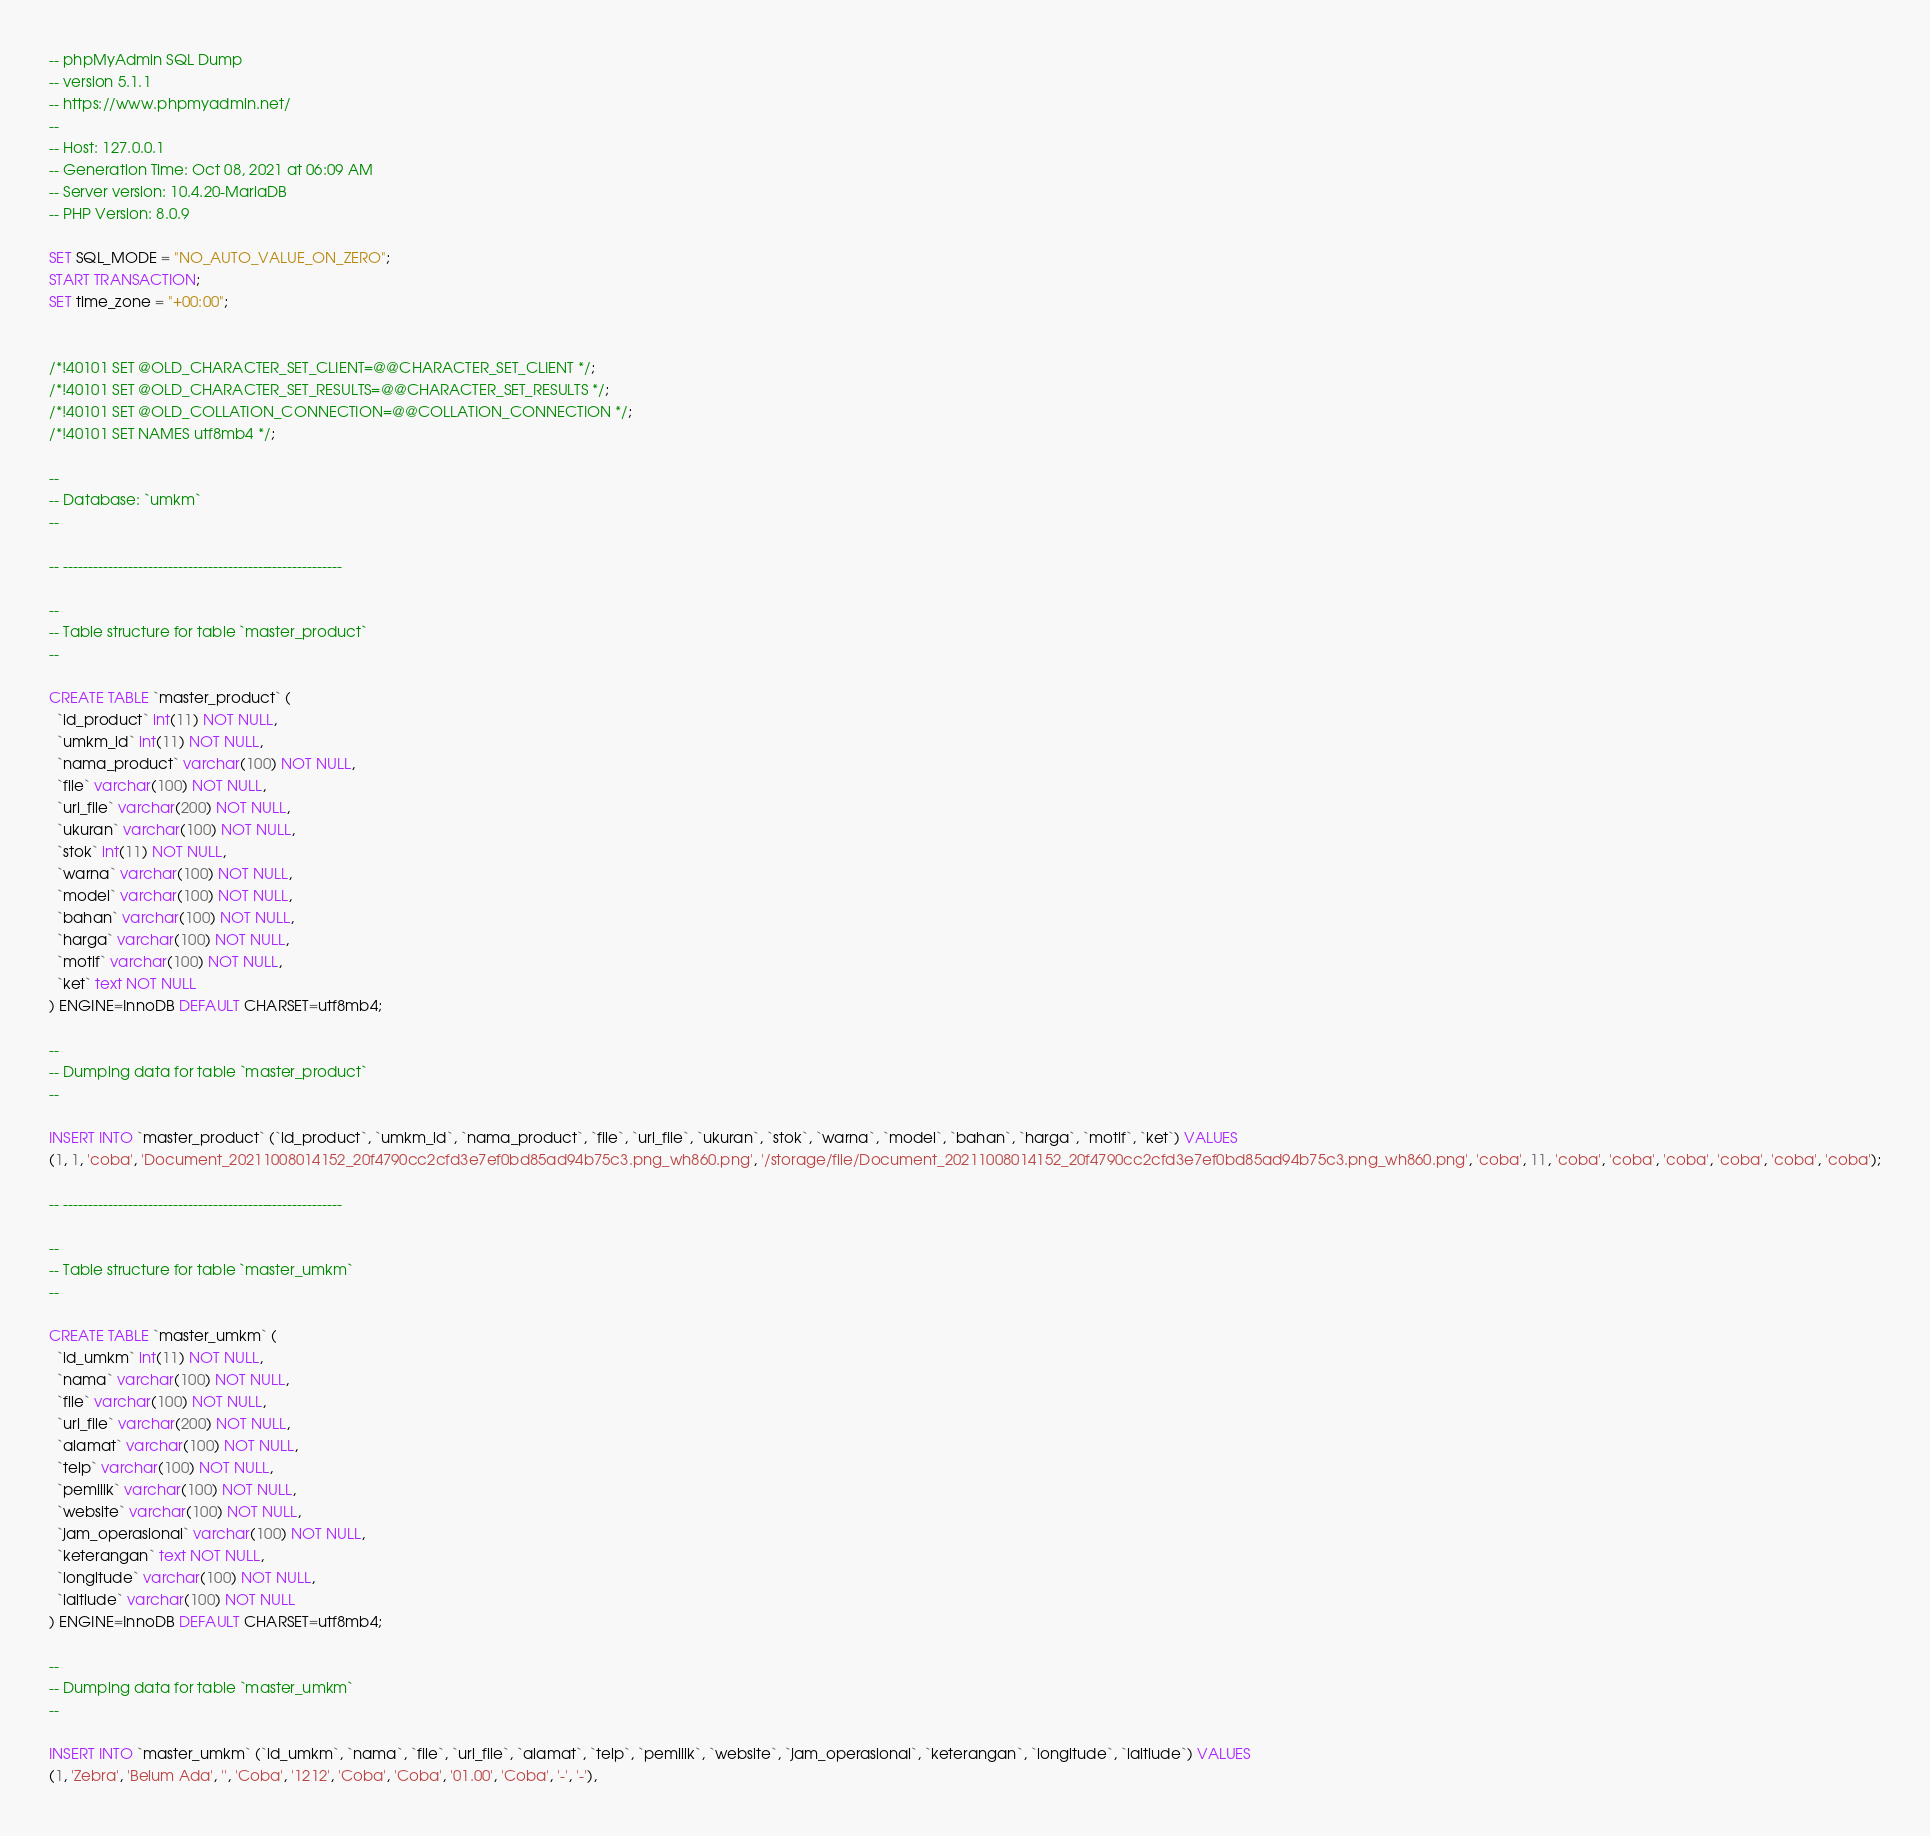Convert code to text. <code><loc_0><loc_0><loc_500><loc_500><_SQL_>-- phpMyAdmin SQL Dump
-- version 5.1.1
-- https://www.phpmyadmin.net/
--
-- Host: 127.0.0.1
-- Generation Time: Oct 08, 2021 at 06:09 AM
-- Server version: 10.4.20-MariaDB
-- PHP Version: 8.0.9

SET SQL_MODE = "NO_AUTO_VALUE_ON_ZERO";
START TRANSACTION;
SET time_zone = "+00:00";


/*!40101 SET @OLD_CHARACTER_SET_CLIENT=@@CHARACTER_SET_CLIENT */;
/*!40101 SET @OLD_CHARACTER_SET_RESULTS=@@CHARACTER_SET_RESULTS */;
/*!40101 SET @OLD_COLLATION_CONNECTION=@@COLLATION_CONNECTION */;
/*!40101 SET NAMES utf8mb4 */;

--
-- Database: `umkm`
--

-- --------------------------------------------------------

--
-- Table structure for table `master_product`
--

CREATE TABLE `master_product` (
  `id_product` int(11) NOT NULL,
  `umkm_id` int(11) NOT NULL,
  `nama_product` varchar(100) NOT NULL,
  `file` varchar(100) NOT NULL,
  `url_file` varchar(200) NOT NULL,
  `ukuran` varchar(100) NOT NULL,
  `stok` int(11) NOT NULL,
  `warna` varchar(100) NOT NULL,
  `model` varchar(100) NOT NULL,
  `bahan` varchar(100) NOT NULL,
  `harga` varchar(100) NOT NULL,
  `motif` varchar(100) NOT NULL,
  `ket` text NOT NULL
) ENGINE=InnoDB DEFAULT CHARSET=utf8mb4;

--
-- Dumping data for table `master_product`
--

INSERT INTO `master_product` (`id_product`, `umkm_id`, `nama_product`, `file`, `url_file`, `ukuran`, `stok`, `warna`, `model`, `bahan`, `harga`, `motif`, `ket`) VALUES
(1, 1, 'coba', 'Document_20211008014152_20f4790cc2cfd3e7ef0bd85ad94b75c3.png_wh860.png', '/storage/file/Document_20211008014152_20f4790cc2cfd3e7ef0bd85ad94b75c3.png_wh860.png', 'coba', 11, 'coba', 'coba', 'coba', 'coba', 'coba', 'coba');

-- --------------------------------------------------------

--
-- Table structure for table `master_umkm`
--

CREATE TABLE `master_umkm` (
  `id_umkm` int(11) NOT NULL,
  `nama` varchar(100) NOT NULL,
  `file` varchar(100) NOT NULL,
  `url_file` varchar(200) NOT NULL,
  `alamat` varchar(100) NOT NULL,
  `telp` varchar(100) NOT NULL,
  `pemilik` varchar(100) NOT NULL,
  `website` varchar(100) NOT NULL,
  `jam_operasional` varchar(100) NOT NULL,
  `keterangan` text NOT NULL,
  `longitude` varchar(100) NOT NULL,
  `laltiude` varchar(100) NOT NULL
) ENGINE=InnoDB DEFAULT CHARSET=utf8mb4;

--
-- Dumping data for table `master_umkm`
--

INSERT INTO `master_umkm` (`id_umkm`, `nama`, `file`, `url_file`, `alamat`, `telp`, `pemilik`, `website`, `jam_operasional`, `keterangan`, `longitude`, `laltiude`) VALUES
(1, 'Zebra', 'Belum Ada', '', 'Coba', '1212', 'Coba', 'Coba', '01.00', 'Coba', '-', '-'),</code> 